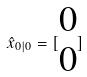<formula> <loc_0><loc_0><loc_500><loc_500>\hat { x } _ { 0 | 0 } = [ \begin{matrix} 0 \\ 0 \end{matrix} ]</formula> 